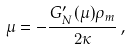Convert formula to latex. <formula><loc_0><loc_0><loc_500><loc_500>\mu = - \frac { G _ { N } ^ { \prime } ( \mu ) \rho _ { m } } { 2 \kappa } \, ,</formula> 